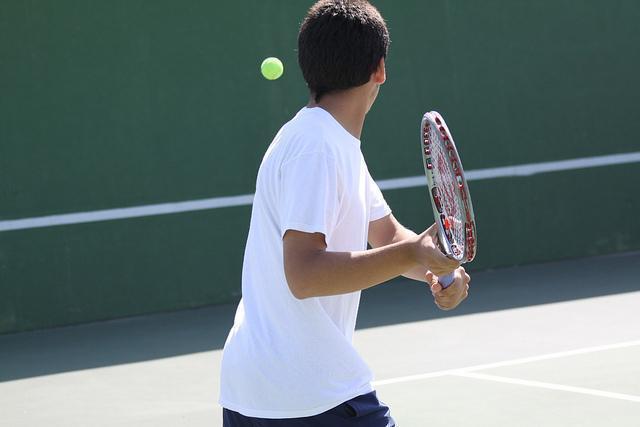What kind of strike is he preparing to do?
Make your selection from the four choices given to correctly answer the question.
Options: Lower hand, upper hand, backhand, forehand. Backhand. 